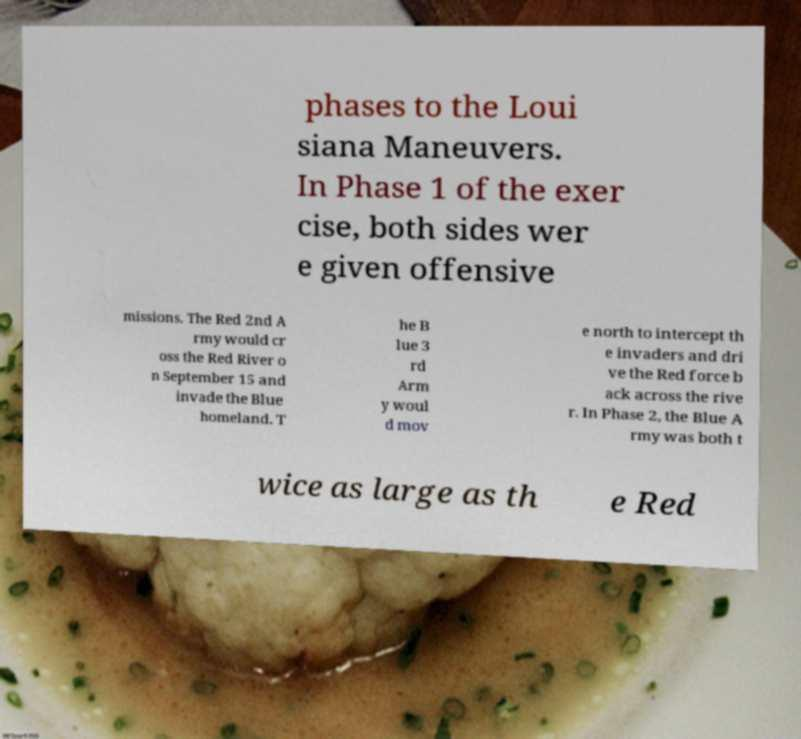I need the written content from this picture converted into text. Can you do that? phases to the Loui siana Maneuvers. In Phase 1 of the exer cise, both sides wer e given offensive missions. The Red 2nd A rmy would cr oss the Red River o n September 15 and invade the Blue homeland. T he B lue 3 rd Arm y woul d mov e north to intercept th e invaders and dri ve the Red force b ack across the rive r. In Phase 2, the Blue A rmy was both t wice as large as th e Red 